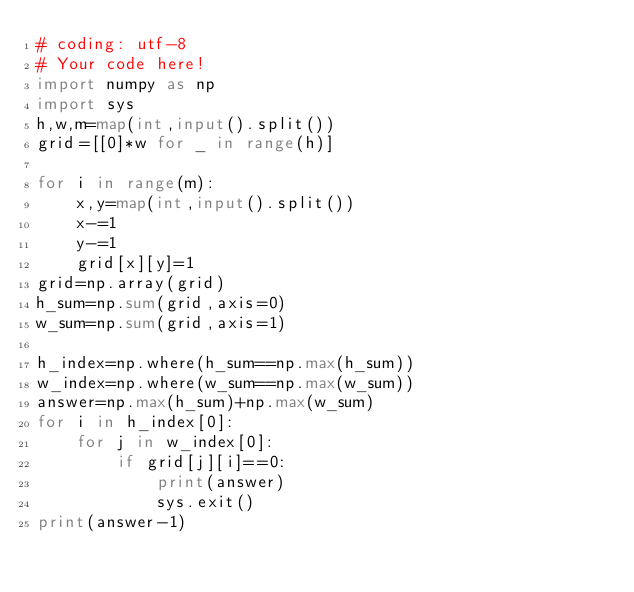Convert code to text. <code><loc_0><loc_0><loc_500><loc_500><_Python_># coding: utf-8
# Your code here!
import numpy as np
import sys
h,w,m=map(int,input().split())
grid=[[0]*w for _ in range(h)]

for i in range(m):
    x,y=map(int,input().split())
    x-=1
    y-=1
    grid[x][y]=1
grid=np.array(grid)
h_sum=np.sum(grid,axis=0)
w_sum=np.sum(grid,axis=1)

h_index=np.where(h_sum==np.max(h_sum))
w_index=np.where(w_sum==np.max(w_sum))
answer=np.max(h_sum)+np.max(w_sum)
for i in h_index[0]:
    for j in w_index[0]:
        if grid[j][i]==0:
            print(answer)
            sys.exit()
print(answer-1)
        </code> 